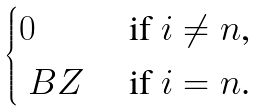Convert formula to latex. <formula><loc_0><loc_0><loc_500><loc_500>\begin{cases} 0 & \text { if $i\not= n$, } \\ \ B Z & \text { if $i=n$.} \end{cases}</formula> 